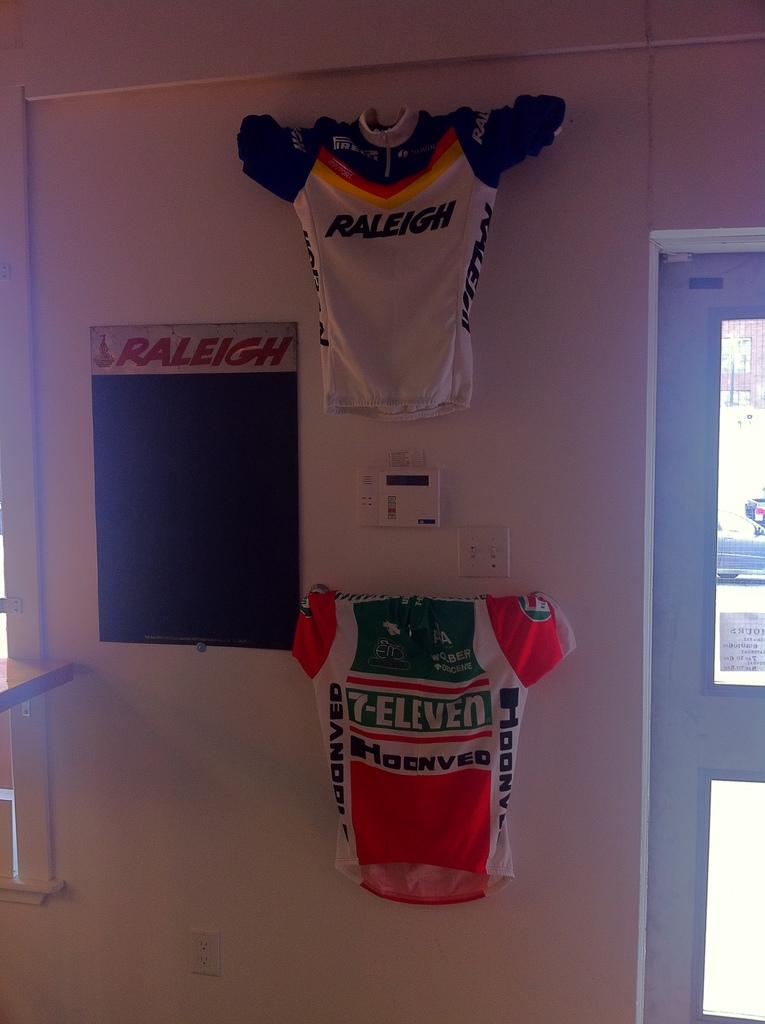What is the primary sponsor of the bottom(orange) jersey?
Your response must be concise. 7-eleven. What word does it say on the jersey on the top?
Make the answer very short. Raleigh. 